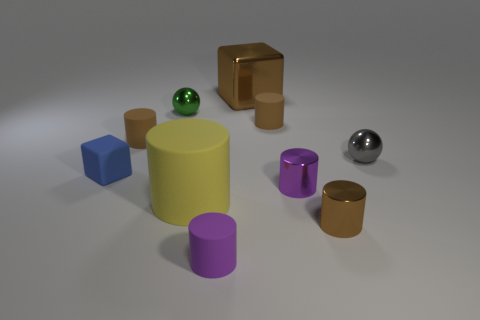How many purple objects are the same shape as the big brown object?
Provide a succinct answer. 0. How big is the rubber cylinder in front of the large object that is in front of the purple metal cylinder?
Offer a terse response. Small. Does the brown metallic block have the same size as the purple metallic cylinder?
Give a very brief answer. No. There is a large object that is behind the small ball on the left side of the tiny gray ball; is there a metal object on the right side of it?
Make the answer very short. Yes. How big is the brown metallic cylinder?
Ensure brevity in your answer.  Small. What number of brown matte cylinders are the same size as the gray thing?
Your response must be concise. 2. What is the material of the other object that is the same shape as the gray object?
Give a very brief answer. Metal. The tiny metal object that is behind the small rubber cube and left of the gray sphere has what shape?
Ensure brevity in your answer.  Sphere. There is a big thing behind the small gray metal ball; what shape is it?
Ensure brevity in your answer.  Cube. What number of things are both behind the blue rubber cube and right of the large matte object?
Offer a very short reply. 3. 